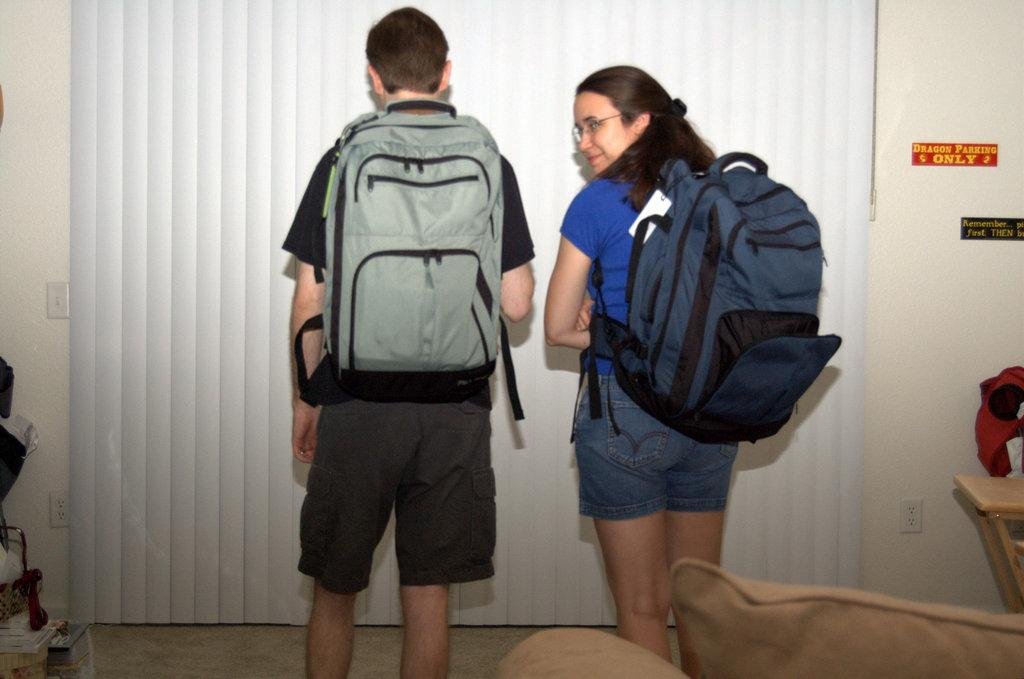<image>
Describe the image concisely. Two kids with backpacks standing next to a sign that says dragon parking only 